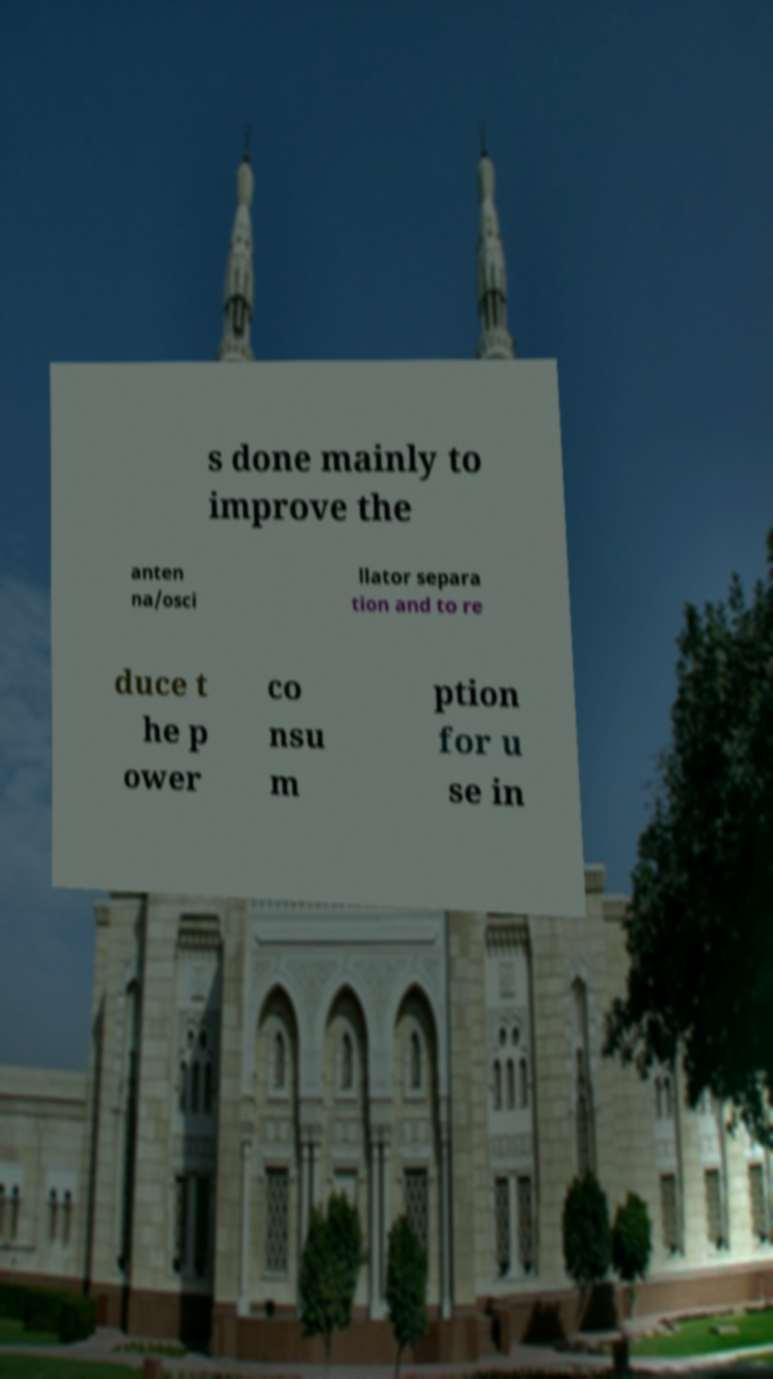Could you assist in decoding the text presented in this image and type it out clearly? s done mainly to improve the anten na/osci llator separa tion and to re duce t he p ower co nsu m ption for u se in 